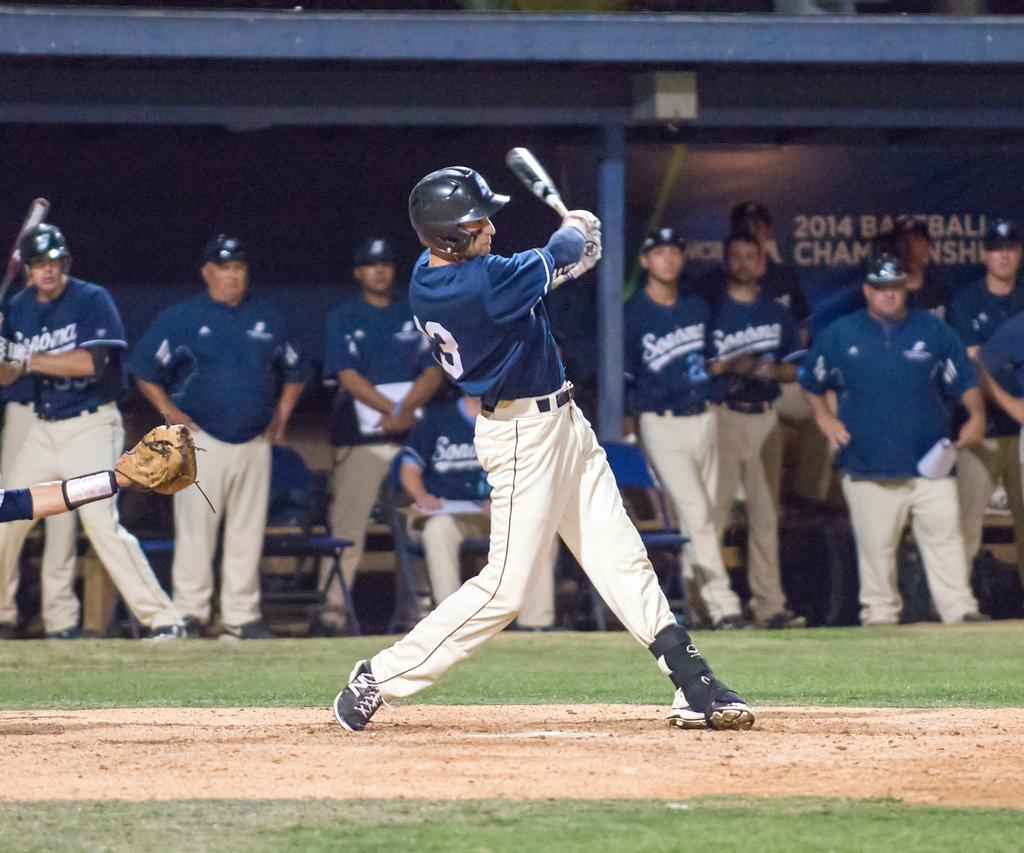<image>
Create a compact narrative representing the image presented. A baseball player at the 2014 Baseball Championship is swinging his bat. 